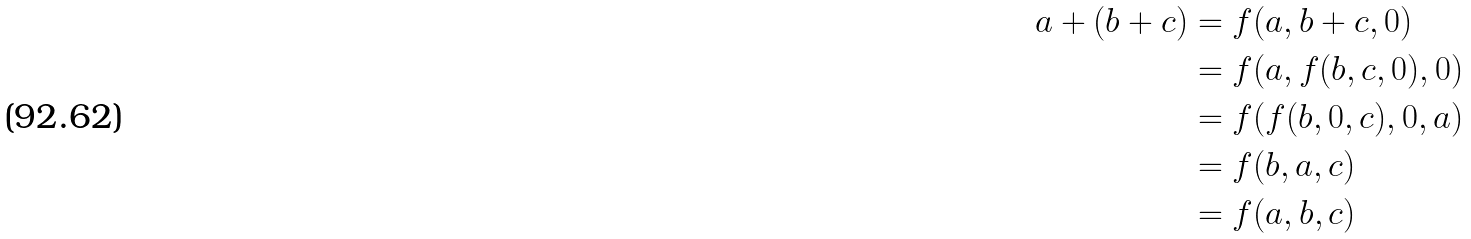<formula> <loc_0><loc_0><loc_500><loc_500>a + ( b + c ) & = f ( a , b + c , 0 ) \\ & = f ( a , f ( b , c , 0 ) , 0 ) \\ & = f ( f ( b , 0 , c ) , 0 , a ) \\ & = f ( b , a , c ) \\ & = f ( a , b , c )</formula> 